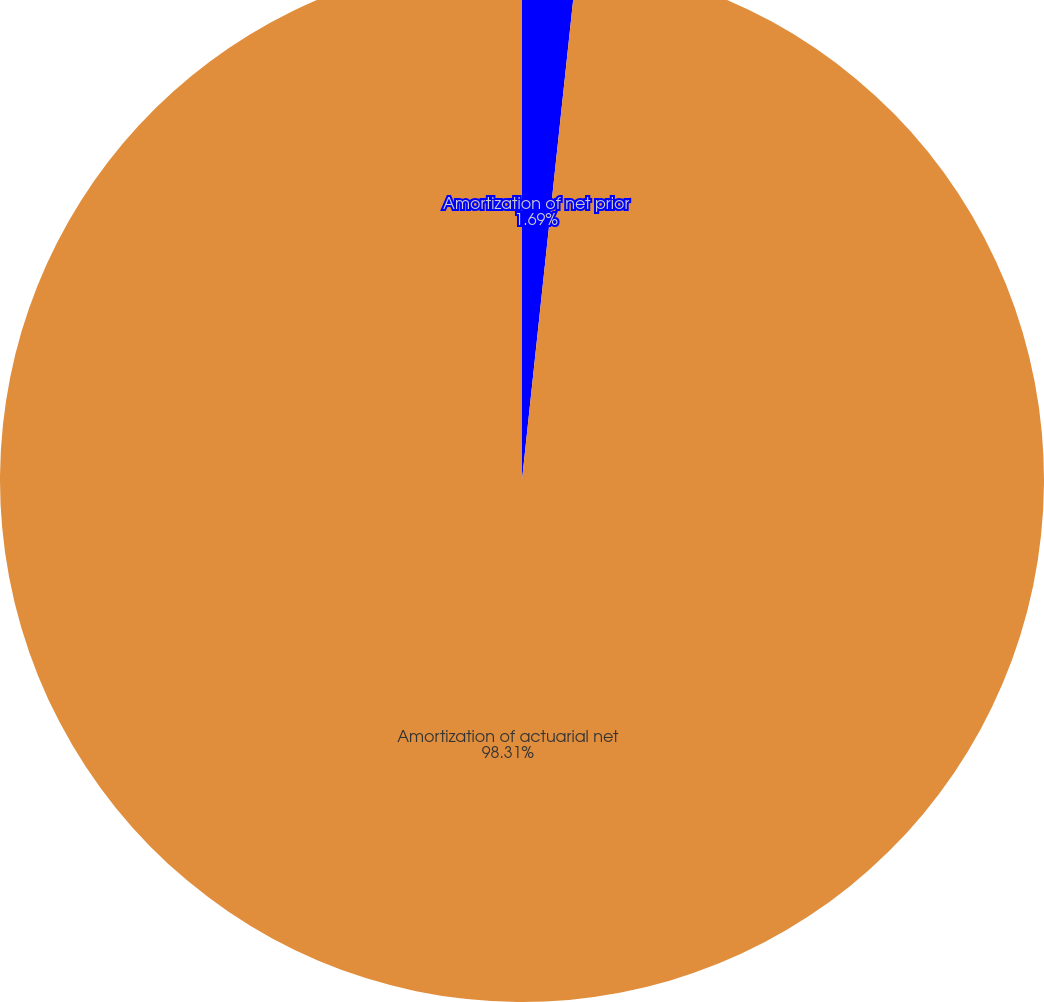Convert chart to OTSL. <chart><loc_0><loc_0><loc_500><loc_500><pie_chart><fcel>Amortization of net prior<fcel>Amortization of actuarial net<nl><fcel>1.69%<fcel>98.31%<nl></chart> 